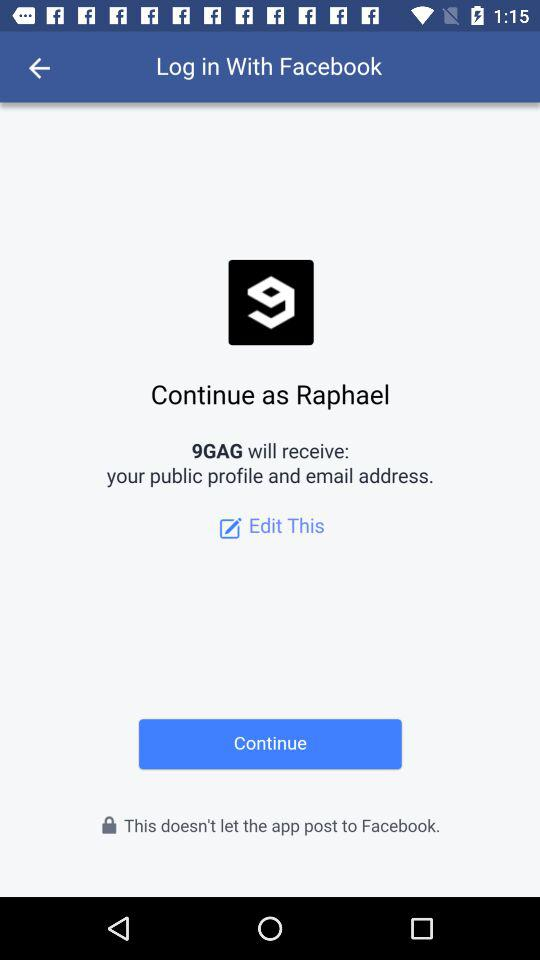What is the login option? The login option is "Facebook". 